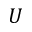Convert formula to latex. <formula><loc_0><loc_0><loc_500><loc_500>U</formula> 